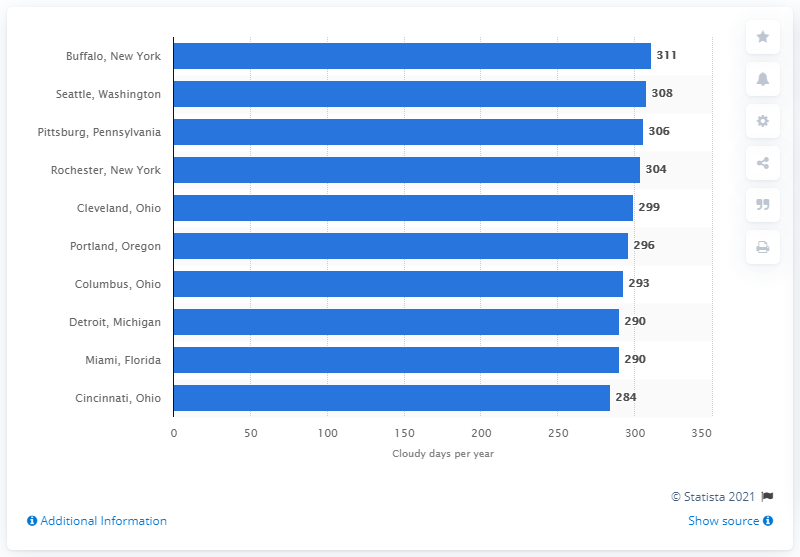Identify some key points in this picture. In 2011, the city of Buffalo experienced 311 days of cloud cover. In 2011, Buffalo, New York had the highest level of partial cloud cover among all cities. 